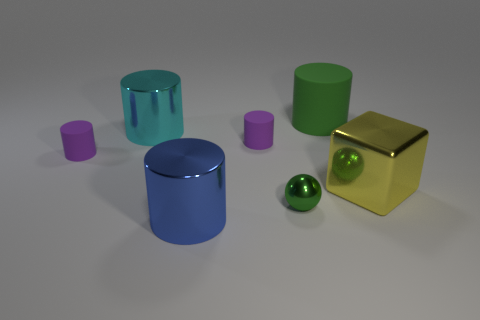Is there a big metal cylinder that has the same color as the big metal block?
Provide a succinct answer. No. There is a shiny cylinder that is in front of the green sphere; does it have the same size as the large green cylinder?
Offer a very short reply. Yes. Are there fewer large blue cylinders than tiny metallic cylinders?
Offer a very short reply. No. Is there another blue object made of the same material as the large blue object?
Keep it short and to the point. No. What is the shape of the small green thing that is left of the large green matte cylinder?
Your answer should be compact. Sphere. There is a large cylinder that is to the right of the blue cylinder; does it have the same color as the small metal thing?
Your answer should be very brief. Yes. Is the number of large cylinders that are on the right side of the large yellow object less than the number of blue metal blocks?
Ensure brevity in your answer.  No. There is a sphere that is made of the same material as the blue cylinder; what color is it?
Give a very brief answer. Green. How big is the thing that is on the right side of the big green object?
Your answer should be compact. Large. Does the tiny green thing have the same material as the big blue thing?
Offer a very short reply. Yes. 